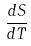<formula> <loc_0><loc_0><loc_500><loc_500>\frac { d S } { d T }</formula> 